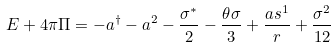<formula> <loc_0><loc_0><loc_500><loc_500>E + 4 \pi \Pi = - a ^ { \dagger } - a ^ { 2 } - \frac { \sigma ^ { \ast } } { 2 } - \frac { \theta \sigma } { 3 } + \frac { a s ^ { 1 } } { r } + \frac { \sigma ^ { 2 } } { 1 2 }</formula> 